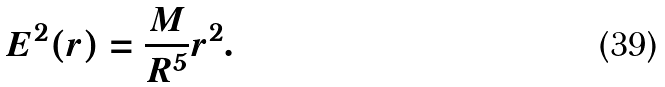Convert formula to latex. <formula><loc_0><loc_0><loc_500><loc_500>E ^ { 2 } ( r ) = \frac { M } { R ^ { 5 } } r ^ { 2 } .</formula> 